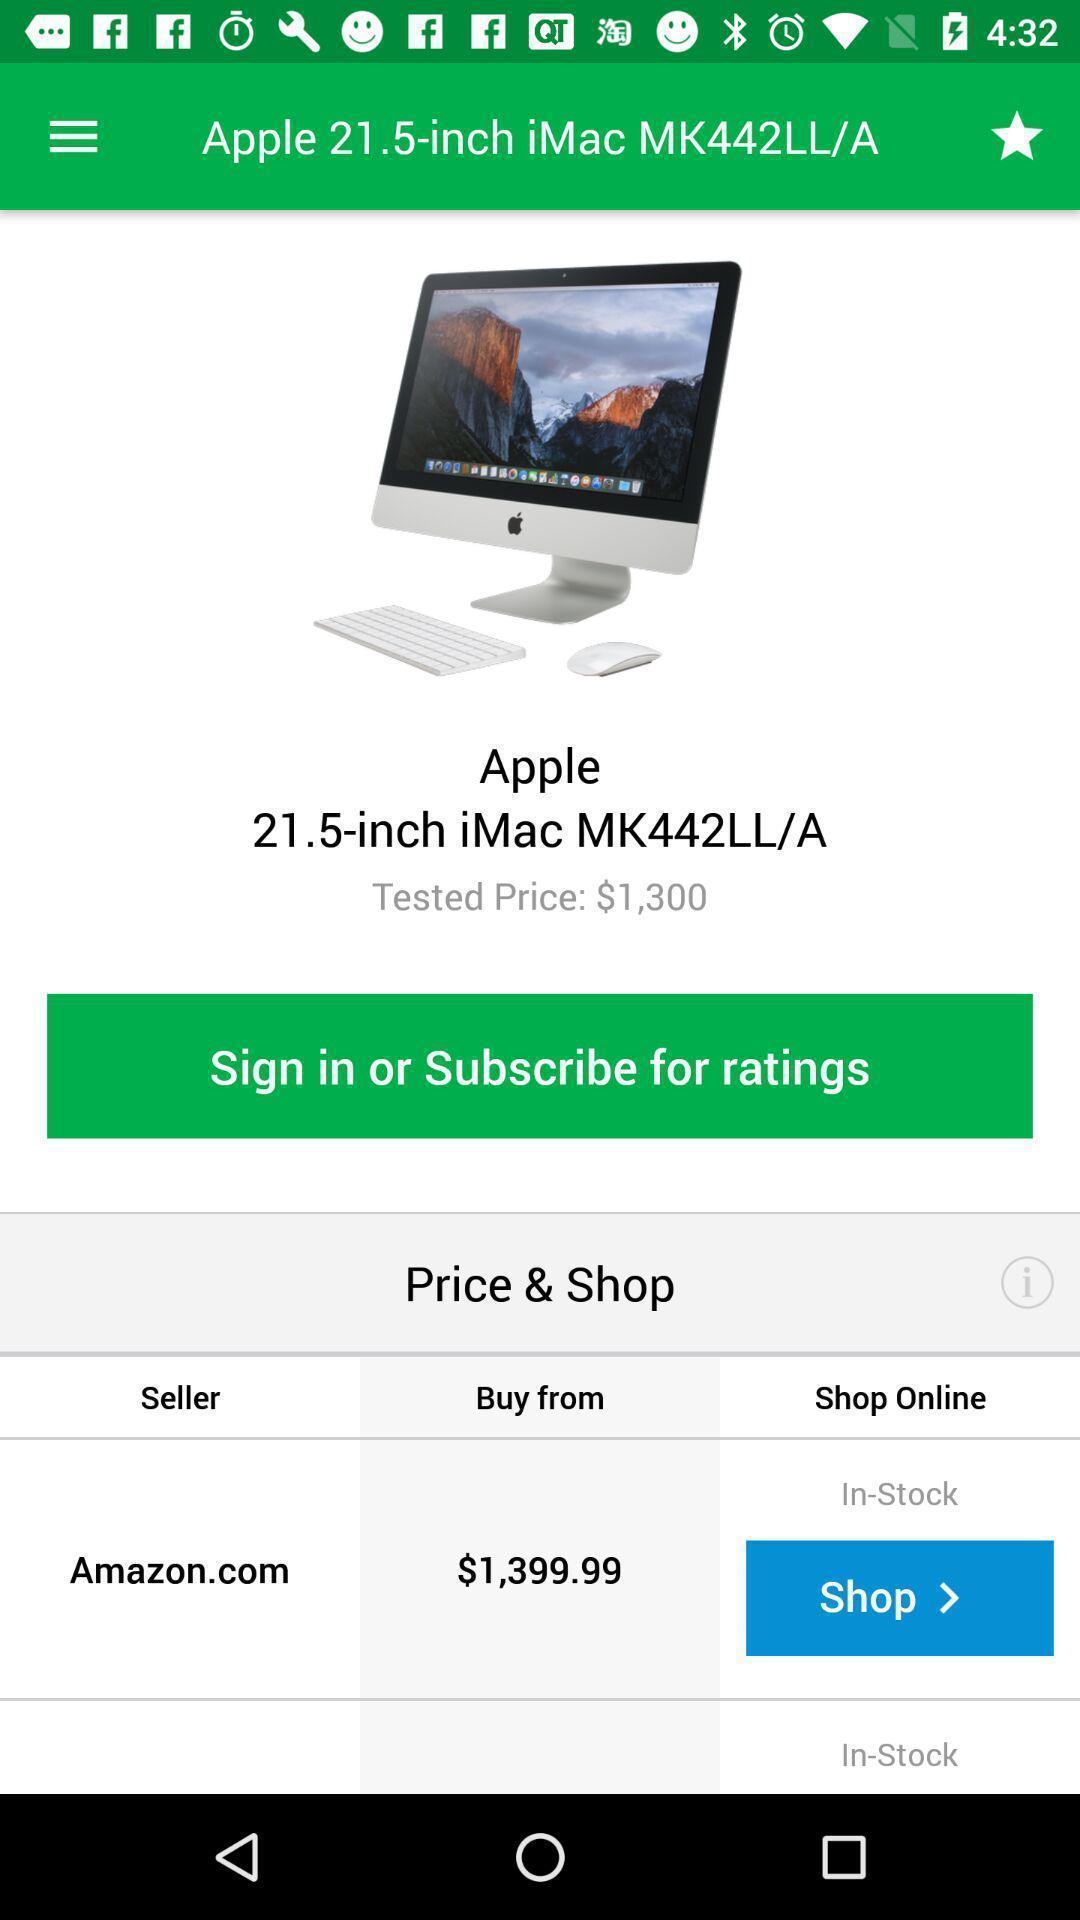Provide a detailed account of this screenshot. Screen page of a shopping app. 